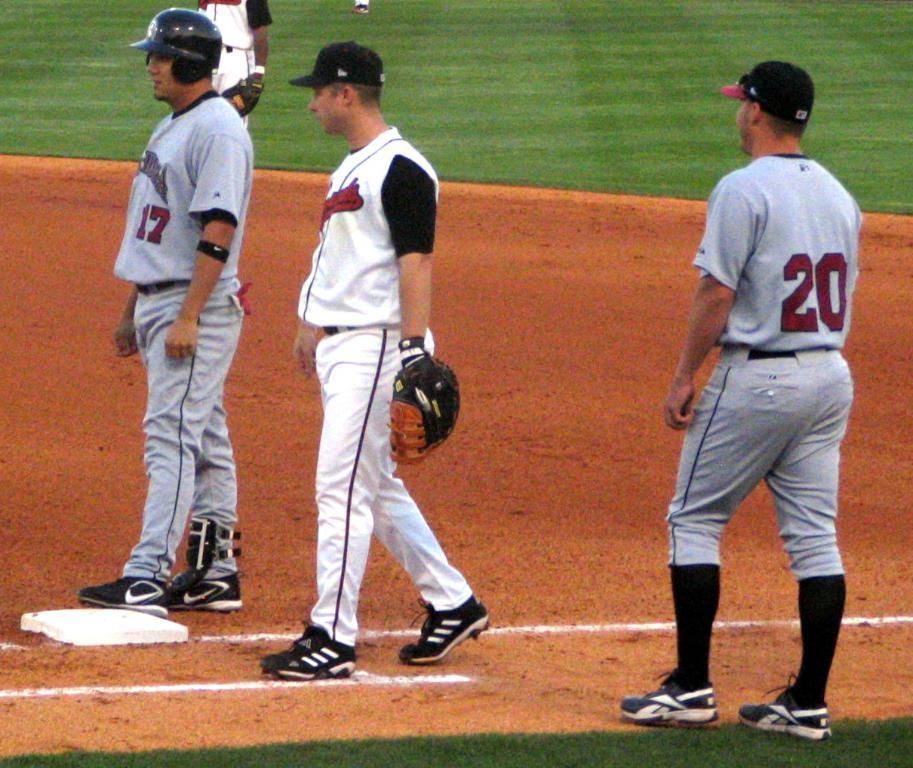<image>
Relay a brief, clear account of the picture shown. Baseball player on the base wearing a gray uniform with a red 17 on it. 